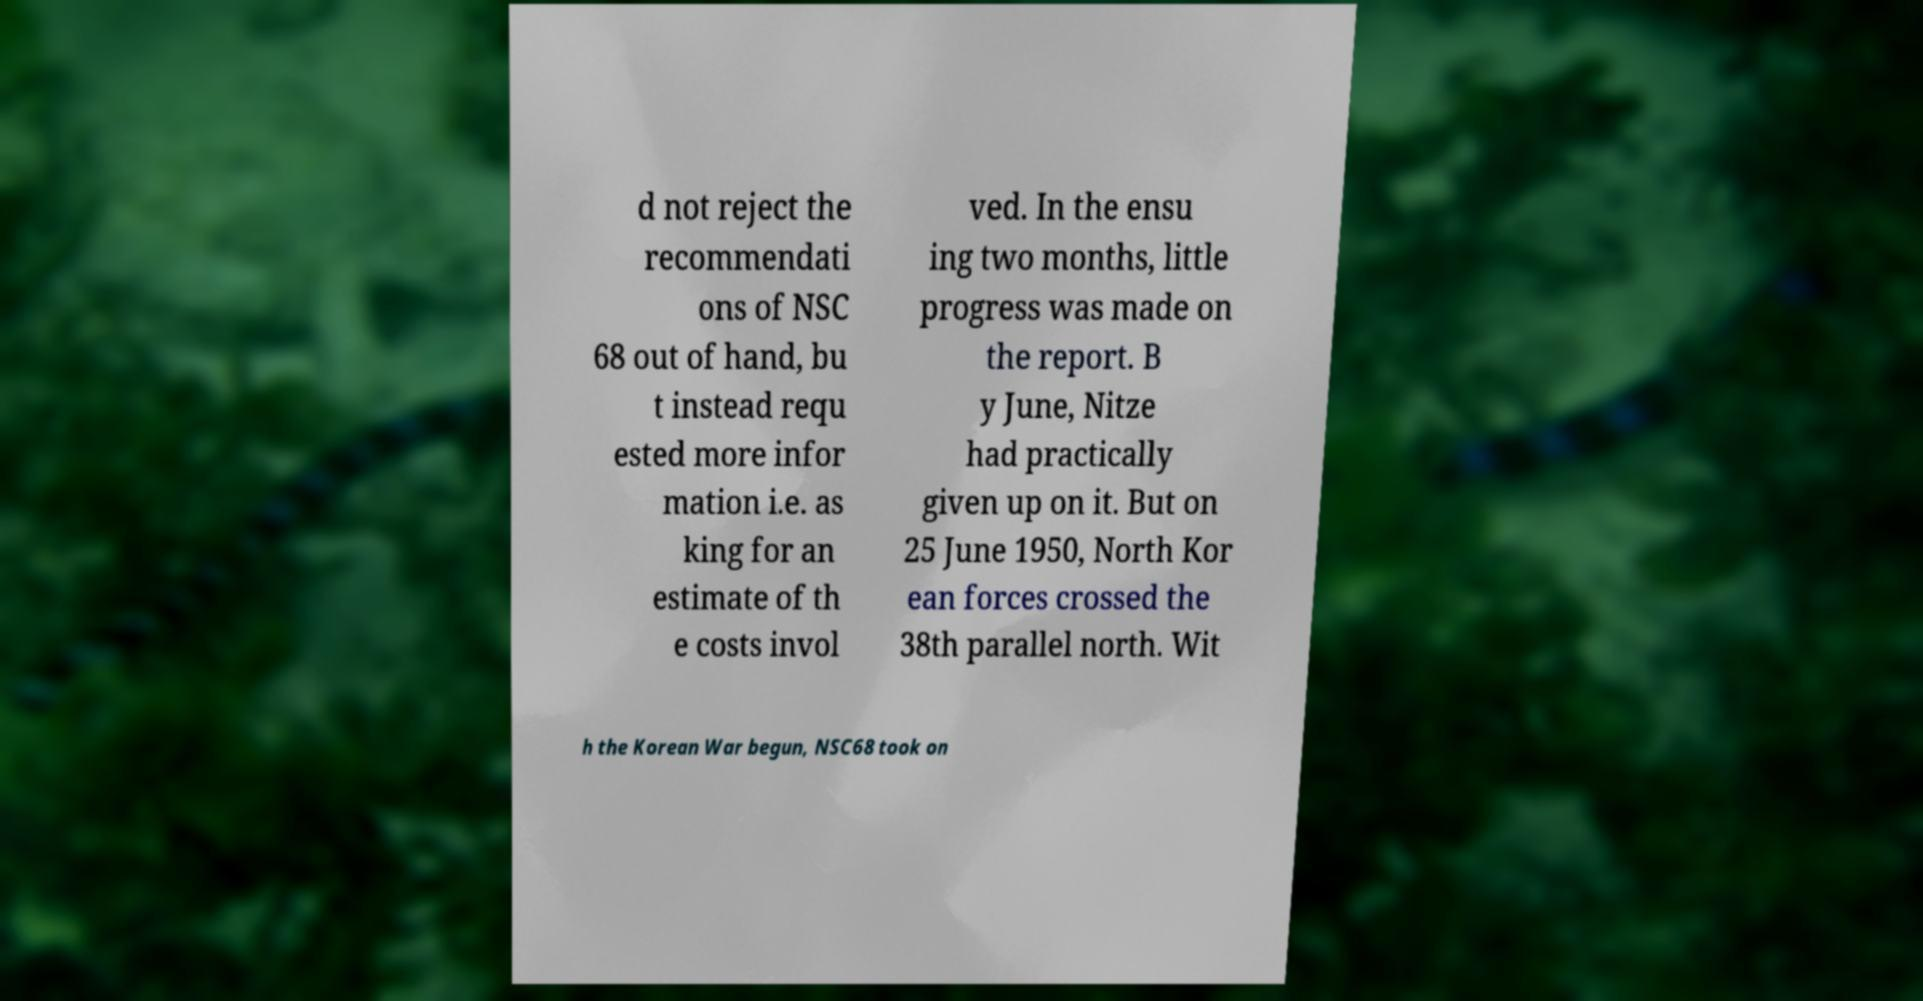I need the written content from this picture converted into text. Can you do that? d not reject the recommendati ons of NSC 68 out of hand, bu t instead requ ested more infor mation i.e. as king for an estimate of th e costs invol ved. In the ensu ing two months, little progress was made on the report. B y June, Nitze had practically given up on it. But on 25 June 1950, North Kor ean forces crossed the 38th parallel north. Wit h the Korean War begun, NSC68 took on 